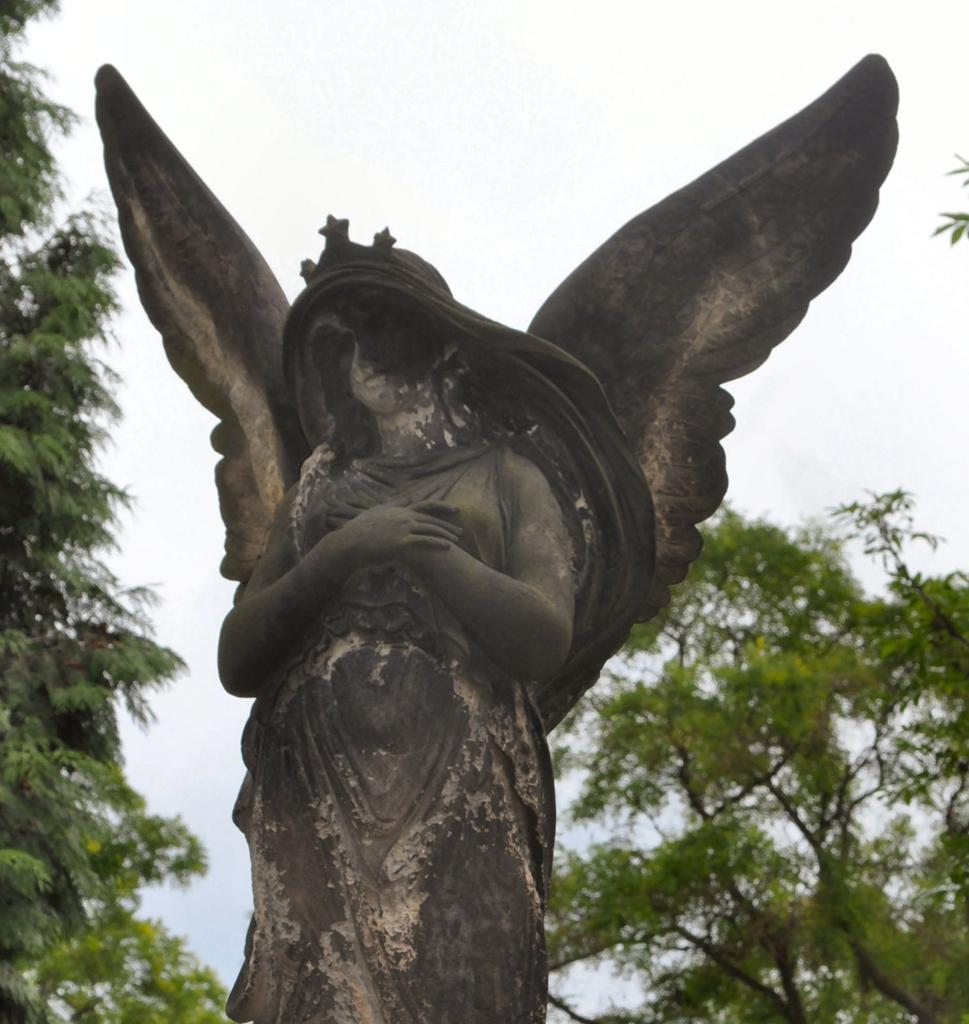What is the main subject in the foreground of the image? There is a statue in the foreground of the image. What can be seen in the background of the image? There are trees and the sky visible in the background of the image. What type of straw is being used to create harmony in the image? There is no straw or reference to harmony present in the image. 